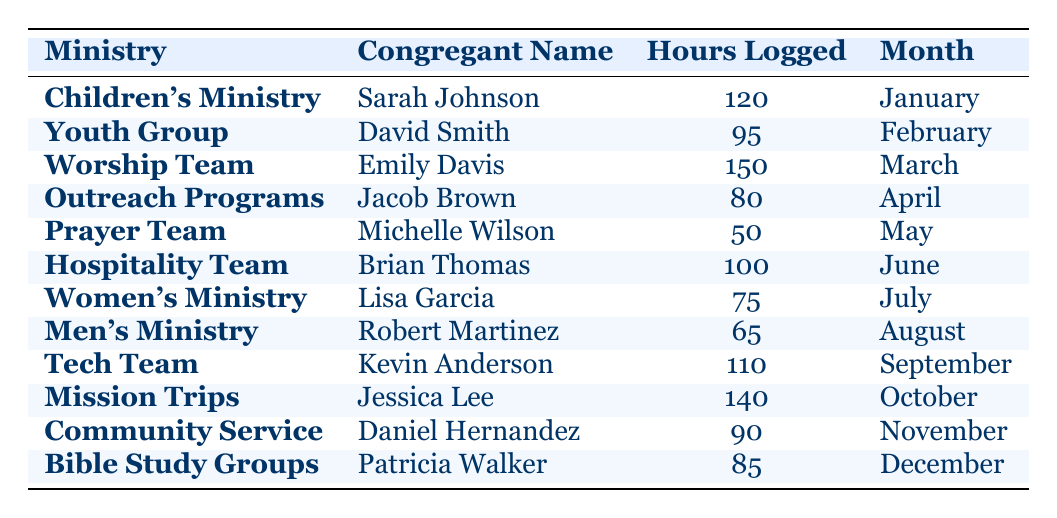What is the total number of hours logged by congregants in the Children's Ministry? There is one entry for the Children's Ministry in the table, which lists Sarah Johnson logging 120 hours in January. Therefore, the total for this ministry is simply 120 hours.
Answer: 120 Which ministry had the highest number of hours logged by a congregant? The table shows each ministry's hours logged. Upon comparison, Worship Team has the highest hours with Emily Davis logging 150 hours in March. There are no other entries that surpass this number.
Answer: Worship Team How many congregants logged more than 100 hours? From the table, the entries with hours logged over 100 are: Sarah Johnson (120), Emily Davis (150), Brian Thomas (100), and Jessica Lee (140). Counting these gives us a total of four congregants with more than 100 hours logged.
Answer: 4 Did anyone from the Men's Ministry log over 80 hours? The entry for the Men's Ministry shows Robert Martinez logged 65 hours, which is less than 80. There are no other entries in this ministry, so the answer is no.
Answer: No What is the average number of hours logged across all ministries? To find the average, we first sum all the hours logged: 120 + 95 + 150 + 80 + 50 + 100 + 75 + 65 + 110 + 140 + 90 + 85 = 1,045. Then we divide this sum by the number of entries (12): 1,045 / 12 = approximately 87.08 hours.
Answer: 87.08 Was the Prayer Team the only ministry where less than 100 hours were logged? The Prayer Team logged 50 hours, which is under 100. Other ministries, such as Women's (75), Men's (65), and Outreach Programs (80) also logged under 100 hours, therefore the statement is false.
Answer: No Which month's congregation had the largest single contribution of hours logged? Looking at the monthly entries, March has Emily Davis from the Worship Team logging the most with 150 hours. Comparing this to other months, there is no larger logged amount than this.
Answer: March How many hours were logged by congregants in the Outreach Programs? The Outreach Programs entry indicates Jacob Brown logged 80 hours in April. There is only one entry for this ministry, making the total hours logged 80.
Answer: 80 